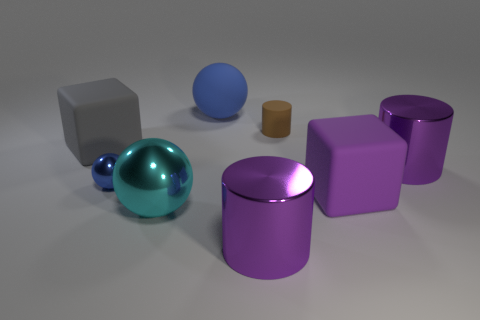What size is the block that is right of the small shiny sphere?
Your answer should be very brief. Large. There is a cube that is to the right of the thing that is behind the brown cylinder; what is its size?
Provide a succinct answer. Large. What material is the purple block that is the same size as the gray cube?
Keep it short and to the point. Rubber. Are there any gray matte things to the right of the cyan thing?
Make the answer very short. No. Are there the same number of purple things that are to the right of the small brown rubber thing and brown matte cylinders?
Make the answer very short. No. The cyan thing that is the same size as the purple matte object is what shape?
Ensure brevity in your answer.  Sphere. What is the material of the small brown cylinder?
Your response must be concise. Rubber. There is a matte thing that is both in front of the tiny brown rubber cylinder and behind the tiny blue metal ball; what color is it?
Keep it short and to the point. Gray. Are there an equal number of large gray rubber things left of the small matte cylinder and big cyan shiny objects that are on the left side of the blue rubber thing?
Give a very brief answer. Yes. The cylinder that is the same material as the big blue thing is what color?
Your response must be concise. Brown. 